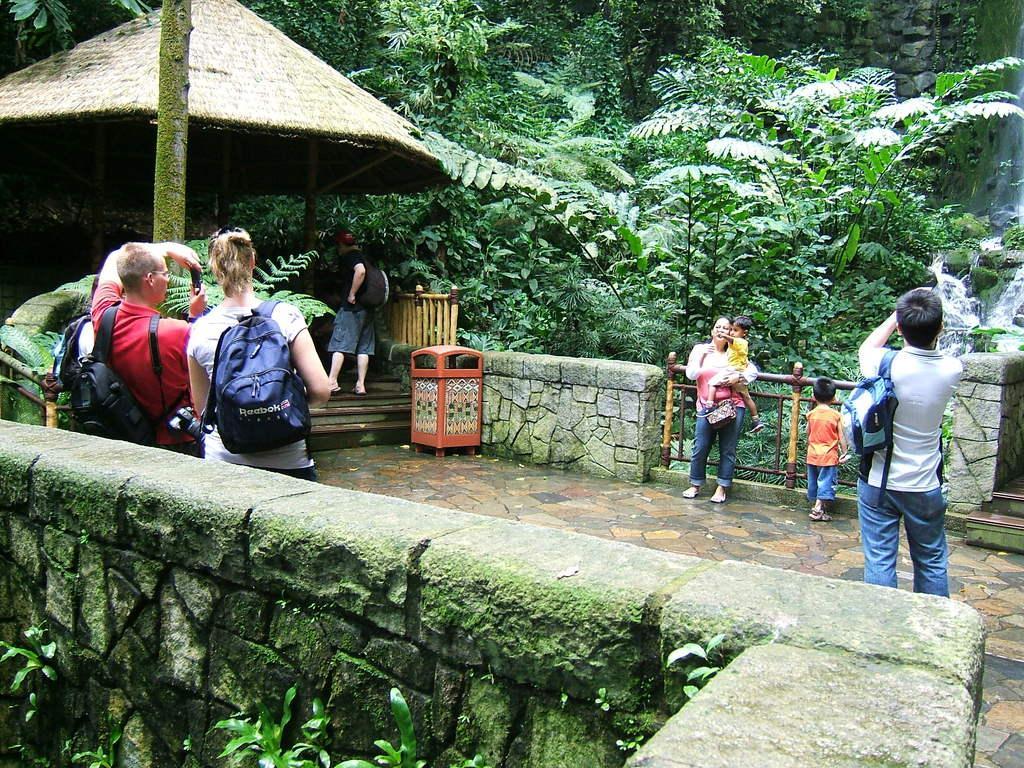Please provide a concise description of this image. In this image there are two persons standing on the floor and taking the picture of the woman who is in front of them. On the left side bottom there is a wall. In the background there are trees. On the left side top there is a hut. On the right side there is a person standing on the floor with a bag to his left hand. On the floor there is a dustbin near the steps. 